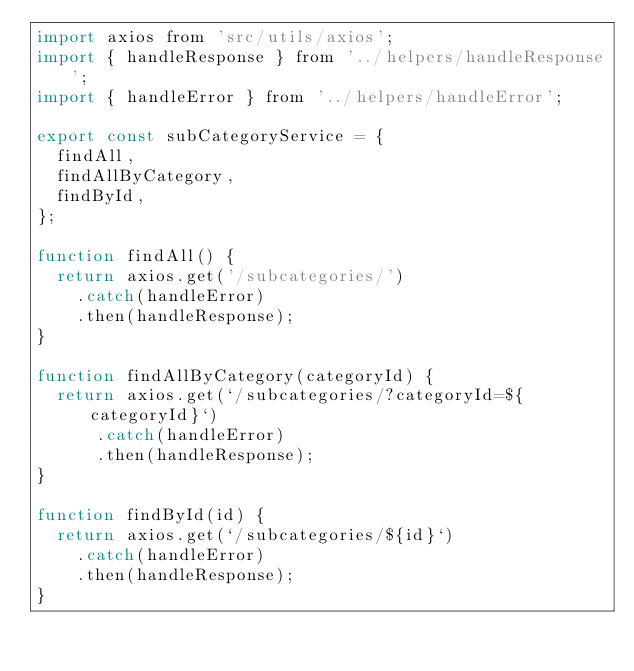Convert code to text. <code><loc_0><loc_0><loc_500><loc_500><_JavaScript_>import axios from 'src/utils/axios';
import { handleResponse } from '../helpers/handleResponse';
import { handleError } from '../helpers/handleError';

export const subCategoryService = {
  findAll,
  findAllByCategory,
  findById,
};

function findAll() {
  return axios.get('/subcategories/')
    .catch(handleError)
    .then(handleResponse);
}

function findAllByCategory(categoryId) {
  return axios.get(`/subcategories/?categoryId=${categoryId}`)
      .catch(handleError)
      .then(handleResponse);
}

function findById(id) {
  return axios.get(`/subcategories/${id}`)
    .catch(handleError)
    .then(handleResponse);
}
</code> 